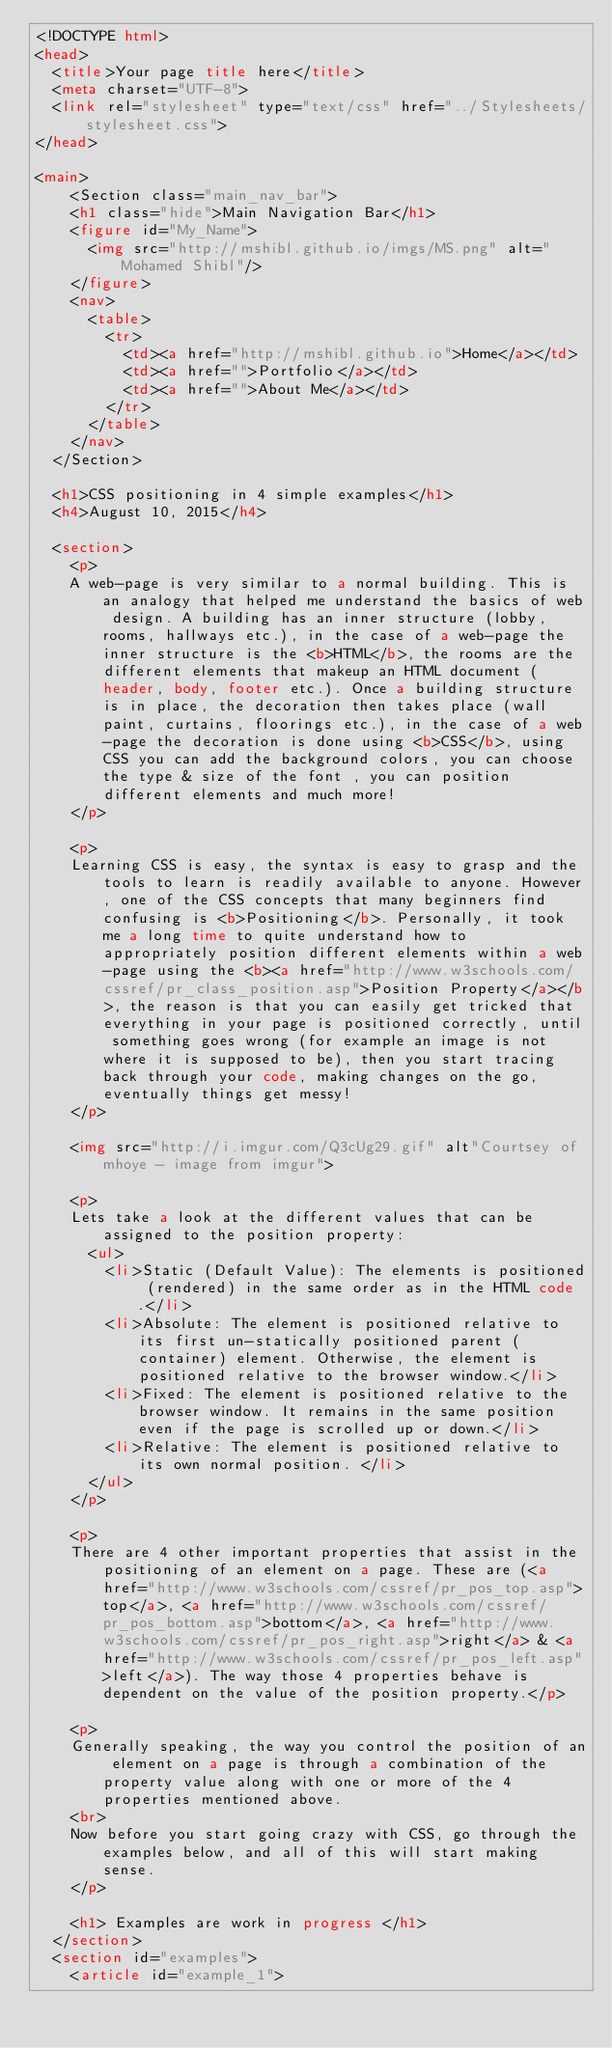<code> <loc_0><loc_0><loc_500><loc_500><_HTML_><!DOCTYPE html>
<head>
  <title>Your page title here</title>
  <meta charset="UTF-8">
  <link rel="stylesheet" type="text/css" href="../Stylesheets/stylesheet.css">
</head>

<main>
    <Section class="main_nav_bar">
    <h1 class="hide">Main Navigation Bar</h1>
    <figure id="My_Name">
      <img src="http://mshibl.github.io/imgs/MS.png" alt="Mohamed Shibl"/>
    </figure>
    <nav>
      <table>
        <tr>
          <td><a href="http://mshibl.github.io">Home</a></td>
          <td><a href="">Portfolio</a></td>
          <td><a href="">About Me</a></td>
        </tr>
      </table>
    </nav>
  </Section>

  <h1>CSS positioning in 4 simple examples</h1>
  <h4>August 10, 2015</h4>

  <section>
    <p>
    A web-page is very similar to a normal building. This is an analogy that helped me understand the basics of web design. A building has an inner structure (lobby, rooms, hallways etc.), in the case of a web-page the inner structure is the <b>HTML</b>, the rooms are the different elements that makeup an HTML document (header, body, footer etc.). Once a building structure is in place, the decoration then takes place (wall paint, curtains, floorings etc.), in the case of a web-page the decoration is done using <b>CSS</b>, using CSS you can add the background colors, you can choose the type & size of the font , you can position different elements and much more!
    </p>

    <p>
    Learning CSS is easy, the syntax is easy to grasp and the tools to learn is readily available to anyone. However, one of the CSS concepts that many beginners find confusing is <b>Positioning</b>. Personally, it took me a long time to quite understand how to appropriately position different elements within a web-page using the <b><a href="http://www.w3schools.com/cssref/pr_class_position.asp">Position Property</a></b>, the reason is that you can easily get tricked that everything in your page is positioned correctly, until something goes wrong (for example an image is not where it is supposed to be), then you start tracing back through your code, making changes on the go, eventually things get messy!
    </p>

    <img src="http://i.imgur.com/Q3cUg29.gif" alt"Courtsey of mhoye - image from imgur">

    <p>
    Lets take a look at the different values that can be assigned to the position property:
      <ul>
        <li>Static (Default Value): The elements is positioned (rendered) in the same order as in the HTML code.</li>
        <li>Absolute: The element is positioned relative to its first un-statically positioned parent (container) element. Otherwise, the element is positioned relative to the browser window.</li>
        <li>Fixed: The element is positioned relative to the browser window. It remains in the same position even if the page is scrolled up or down.</li>
        <li>Relative: The element is positioned relative to its own normal position. </li>
      </ul>
    </p>

    <p>
    There are 4 other important properties that assist in the positioning of an element on a page. These are (<a href="http://www.w3schools.com/cssref/pr_pos_top.asp">top</a>, <a href="http://www.w3schools.com/cssref/pr_pos_bottom.asp">bottom</a>, <a href="http://www.w3schools.com/cssref/pr_pos_right.asp">right</a> & <a href="http://www.w3schools.com/cssref/pr_pos_left.asp">left</a>). The way those 4 properties behave is dependent on the value of the position property.</p>

    <p>
    Generally speaking, the way you control the position of an element on a page is through a combination of the property value along with one or more of the 4 properties mentioned above.
    <br>
    Now before you start going crazy with CSS, go through the examples below, and all of this will start making sense.
    </p>

    <h1> Examples are work in progress </h1>
  </section>
  <section id="examples">
    <article id="example_1"></code> 